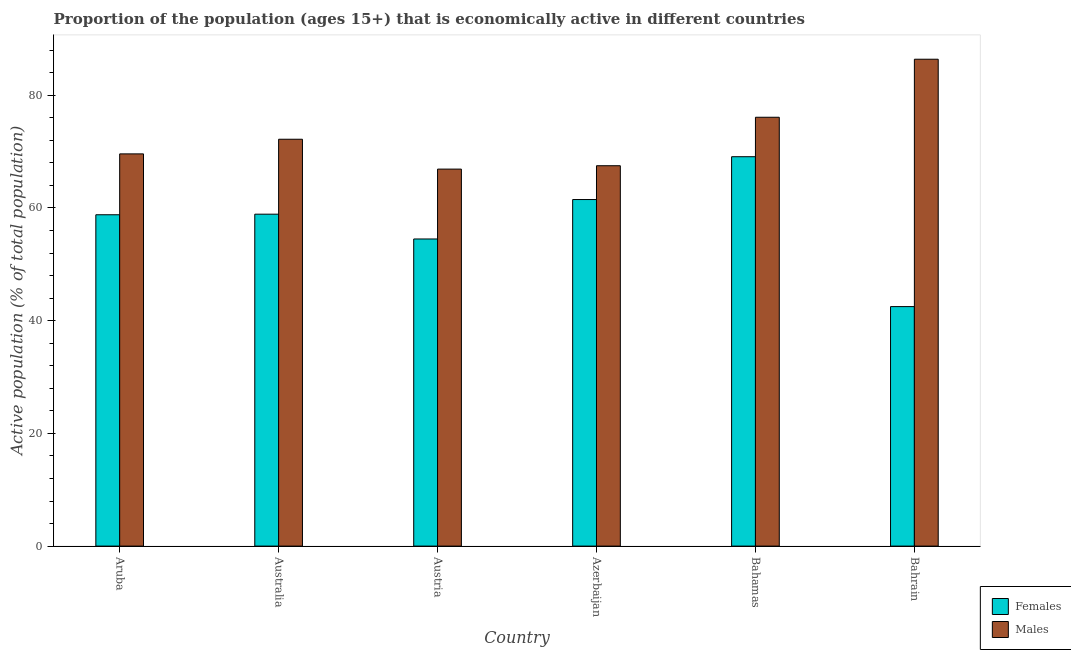How many groups of bars are there?
Make the answer very short. 6. How many bars are there on the 6th tick from the left?
Ensure brevity in your answer.  2. What is the label of the 5th group of bars from the left?
Give a very brief answer. Bahamas. What is the percentage of economically active male population in Azerbaijan?
Offer a terse response. 67.5. Across all countries, what is the maximum percentage of economically active female population?
Your answer should be compact. 69.1. Across all countries, what is the minimum percentage of economically active male population?
Provide a short and direct response. 66.9. In which country was the percentage of economically active male population maximum?
Provide a short and direct response. Bahrain. In which country was the percentage of economically active male population minimum?
Give a very brief answer. Austria. What is the total percentage of economically active male population in the graph?
Keep it short and to the point. 438.7. What is the difference between the percentage of economically active male population in Aruba and that in Bahrain?
Make the answer very short. -16.8. What is the difference between the percentage of economically active female population in Bahamas and the percentage of economically active male population in Austria?
Make the answer very short. 2.2. What is the average percentage of economically active female population per country?
Provide a succinct answer. 57.55. In how many countries, is the percentage of economically active female population greater than 76 %?
Make the answer very short. 0. What is the ratio of the percentage of economically active female population in Austria to that in Azerbaijan?
Offer a very short reply. 0.89. Is the percentage of economically active male population in Australia less than that in Bahrain?
Ensure brevity in your answer.  Yes. Is the difference between the percentage of economically active male population in Australia and Austria greater than the difference between the percentage of economically active female population in Australia and Austria?
Provide a succinct answer. Yes. What is the difference between the highest and the second highest percentage of economically active male population?
Provide a short and direct response. 10.3. What is the difference between the highest and the lowest percentage of economically active male population?
Provide a succinct answer. 19.5. In how many countries, is the percentage of economically active male population greater than the average percentage of economically active male population taken over all countries?
Provide a short and direct response. 2. What does the 2nd bar from the left in Australia represents?
Offer a very short reply. Males. What does the 1st bar from the right in Bahamas represents?
Give a very brief answer. Males. Are the values on the major ticks of Y-axis written in scientific E-notation?
Give a very brief answer. No. How many legend labels are there?
Your answer should be compact. 2. How are the legend labels stacked?
Provide a succinct answer. Vertical. What is the title of the graph?
Give a very brief answer. Proportion of the population (ages 15+) that is economically active in different countries. What is the label or title of the Y-axis?
Provide a succinct answer. Active population (% of total population). What is the Active population (% of total population) in Females in Aruba?
Your response must be concise. 58.8. What is the Active population (% of total population) of Males in Aruba?
Your answer should be compact. 69.6. What is the Active population (% of total population) in Females in Australia?
Offer a very short reply. 58.9. What is the Active population (% of total population) of Males in Australia?
Offer a very short reply. 72.2. What is the Active population (% of total population) in Females in Austria?
Give a very brief answer. 54.5. What is the Active population (% of total population) of Males in Austria?
Give a very brief answer. 66.9. What is the Active population (% of total population) in Females in Azerbaijan?
Keep it short and to the point. 61.5. What is the Active population (% of total population) of Males in Azerbaijan?
Offer a very short reply. 67.5. What is the Active population (% of total population) in Females in Bahamas?
Your answer should be very brief. 69.1. What is the Active population (% of total population) of Males in Bahamas?
Provide a succinct answer. 76.1. What is the Active population (% of total population) of Females in Bahrain?
Make the answer very short. 42.5. What is the Active population (% of total population) in Males in Bahrain?
Your response must be concise. 86.4. Across all countries, what is the maximum Active population (% of total population) of Females?
Offer a terse response. 69.1. Across all countries, what is the maximum Active population (% of total population) of Males?
Offer a very short reply. 86.4. Across all countries, what is the minimum Active population (% of total population) in Females?
Your answer should be compact. 42.5. Across all countries, what is the minimum Active population (% of total population) of Males?
Keep it short and to the point. 66.9. What is the total Active population (% of total population) of Females in the graph?
Your response must be concise. 345.3. What is the total Active population (% of total population) of Males in the graph?
Ensure brevity in your answer.  438.7. What is the difference between the Active population (% of total population) of Females in Aruba and that in Australia?
Keep it short and to the point. -0.1. What is the difference between the Active population (% of total population) of Females in Aruba and that in Austria?
Give a very brief answer. 4.3. What is the difference between the Active population (% of total population) in Males in Aruba and that in Austria?
Your response must be concise. 2.7. What is the difference between the Active population (% of total population) of Females in Aruba and that in Azerbaijan?
Keep it short and to the point. -2.7. What is the difference between the Active population (% of total population) in Males in Aruba and that in Bahamas?
Your answer should be compact. -6.5. What is the difference between the Active population (% of total population) of Males in Aruba and that in Bahrain?
Offer a terse response. -16.8. What is the difference between the Active population (% of total population) of Females in Australia and that in Azerbaijan?
Keep it short and to the point. -2.6. What is the difference between the Active population (% of total population) of Males in Australia and that in Azerbaijan?
Keep it short and to the point. 4.7. What is the difference between the Active population (% of total population) of Females in Australia and that in Bahrain?
Offer a very short reply. 16.4. What is the difference between the Active population (% of total population) in Females in Austria and that in Azerbaijan?
Ensure brevity in your answer.  -7. What is the difference between the Active population (% of total population) of Females in Austria and that in Bahamas?
Your answer should be compact. -14.6. What is the difference between the Active population (% of total population) of Males in Austria and that in Bahamas?
Give a very brief answer. -9.2. What is the difference between the Active population (% of total population) of Males in Austria and that in Bahrain?
Give a very brief answer. -19.5. What is the difference between the Active population (% of total population) in Females in Azerbaijan and that in Bahamas?
Provide a succinct answer. -7.6. What is the difference between the Active population (% of total population) in Males in Azerbaijan and that in Bahrain?
Make the answer very short. -18.9. What is the difference between the Active population (% of total population) of Females in Bahamas and that in Bahrain?
Offer a very short reply. 26.6. What is the difference between the Active population (% of total population) in Females in Aruba and the Active population (% of total population) in Males in Bahamas?
Provide a succinct answer. -17.3. What is the difference between the Active population (% of total population) in Females in Aruba and the Active population (% of total population) in Males in Bahrain?
Make the answer very short. -27.6. What is the difference between the Active population (% of total population) of Females in Australia and the Active population (% of total population) of Males in Azerbaijan?
Keep it short and to the point. -8.6. What is the difference between the Active population (% of total population) in Females in Australia and the Active population (% of total population) in Males in Bahamas?
Keep it short and to the point. -17.2. What is the difference between the Active population (% of total population) of Females in Australia and the Active population (% of total population) of Males in Bahrain?
Give a very brief answer. -27.5. What is the difference between the Active population (% of total population) in Females in Austria and the Active population (% of total population) in Males in Bahamas?
Your answer should be very brief. -21.6. What is the difference between the Active population (% of total population) of Females in Austria and the Active population (% of total population) of Males in Bahrain?
Your answer should be compact. -31.9. What is the difference between the Active population (% of total population) in Females in Azerbaijan and the Active population (% of total population) in Males in Bahamas?
Ensure brevity in your answer.  -14.6. What is the difference between the Active population (% of total population) in Females in Azerbaijan and the Active population (% of total population) in Males in Bahrain?
Offer a very short reply. -24.9. What is the difference between the Active population (% of total population) of Females in Bahamas and the Active population (% of total population) of Males in Bahrain?
Offer a terse response. -17.3. What is the average Active population (% of total population) in Females per country?
Keep it short and to the point. 57.55. What is the average Active population (% of total population) in Males per country?
Your answer should be compact. 73.12. What is the difference between the Active population (% of total population) of Females and Active population (% of total population) of Males in Austria?
Make the answer very short. -12.4. What is the difference between the Active population (% of total population) in Females and Active population (% of total population) in Males in Azerbaijan?
Provide a succinct answer. -6. What is the difference between the Active population (% of total population) in Females and Active population (% of total population) in Males in Bahrain?
Provide a short and direct response. -43.9. What is the ratio of the Active population (% of total population) of Females in Aruba to that in Australia?
Provide a succinct answer. 1. What is the ratio of the Active population (% of total population) in Females in Aruba to that in Austria?
Give a very brief answer. 1.08. What is the ratio of the Active population (% of total population) of Males in Aruba to that in Austria?
Keep it short and to the point. 1.04. What is the ratio of the Active population (% of total population) of Females in Aruba to that in Azerbaijan?
Keep it short and to the point. 0.96. What is the ratio of the Active population (% of total population) in Males in Aruba to that in Azerbaijan?
Keep it short and to the point. 1.03. What is the ratio of the Active population (% of total population) of Females in Aruba to that in Bahamas?
Make the answer very short. 0.85. What is the ratio of the Active population (% of total population) in Males in Aruba to that in Bahamas?
Offer a terse response. 0.91. What is the ratio of the Active population (% of total population) of Females in Aruba to that in Bahrain?
Offer a terse response. 1.38. What is the ratio of the Active population (% of total population) in Males in Aruba to that in Bahrain?
Your response must be concise. 0.81. What is the ratio of the Active population (% of total population) of Females in Australia to that in Austria?
Ensure brevity in your answer.  1.08. What is the ratio of the Active population (% of total population) in Males in Australia to that in Austria?
Provide a succinct answer. 1.08. What is the ratio of the Active population (% of total population) of Females in Australia to that in Azerbaijan?
Your answer should be very brief. 0.96. What is the ratio of the Active population (% of total population) of Males in Australia to that in Azerbaijan?
Offer a very short reply. 1.07. What is the ratio of the Active population (% of total population) in Females in Australia to that in Bahamas?
Provide a short and direct response. 0.85. What is the ratio of the Active population (% of total population) in Males in Australia to that in Bahamas?
Keep it short and to the point. 0.95. What is the ratio of the Active population (% of total population) of Females in Australia to that in Bahrain?
Provide a succinct answer. 1.39. What is the ratio of the Active population (% of total population) of Males in Australia to that in Bahrain?
Offer a terse response. 0.84. What is the ratio of the Active population (% of total population) of Females in Austria to that in Azerbaijan?
Your answer should be very brief. 0.89. What is the ratio of the Active population (% of total population) of Males in Austria to that in Azerbaijan?
Your answer should be compact. 0.99. What is the ratio of the Active population (% of total population) of Females in Austria to that in Bahamas?
Your answer should be very brief. 0.79. What is the ratio of the Active population (% of total population) in Males in Austria to that in Bahamas?
Make the answer very short. 0.88. What is the ratio of the Active population (% of total population) of Females in Austria to that in Bahrain?
Offer a terse response. 1.28. What is the ratio of the Active population (% of total population) of Males in Austria to that in Bahrain?
Offer a terse response. 0.77. What is the ratio of the Active population (% of total population) of Females in Azerbaijan to that in Bahamas?
Offer a very short reply. 0.89. What is the ratio of the Active population (% of total population) of Males in Azerbaijan to that in Bahamas?
Offer a very short reply. 0.89. What is the ratio of the Active population (% of total population) in Females in Azerbaijan to that in Bahrain?
Ensure brevity in your answer.  1.45. What is the ratio of the Active population (% of total population) in Males in Azerbaijan to that in Bahrain?
Offer a very short reply. 0.78. What is the ratio of the Active population (% of total population) of Females in Bahamas to that in Bahrain?
Your answer should be very brief. 1.63. What is the ratio of the Active population (% of total population) of Males in Bahamas to that in Bahrain?
Your answer should be very brief. 0.88. What is the difference between the highest and the second highest Active population (% of total population) of Females?
Provide a short and direct response. 7.6. What is the difference between the highest and the second highest Active population (% of total population) of Males?
Give a very brief answer. 10.3. What is the difference between the highest and the lowest Active population (% of total population) of Females?
Ensure brevity in your answer.  26.6. 